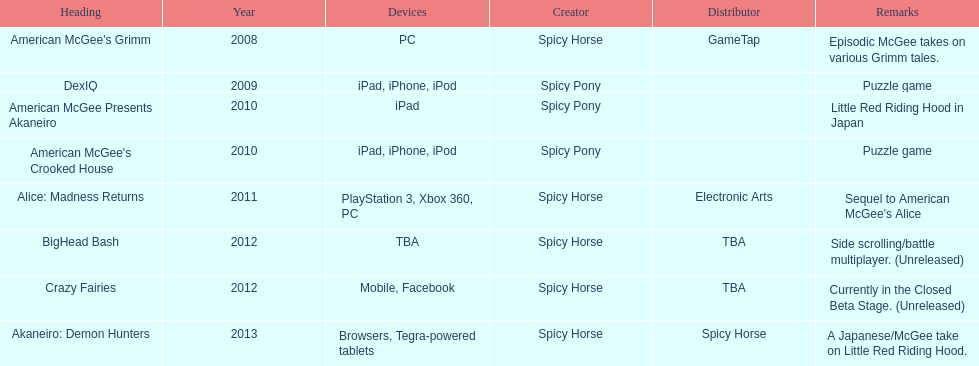What is the foremost caption on this graph? American McGee's Grimm. 